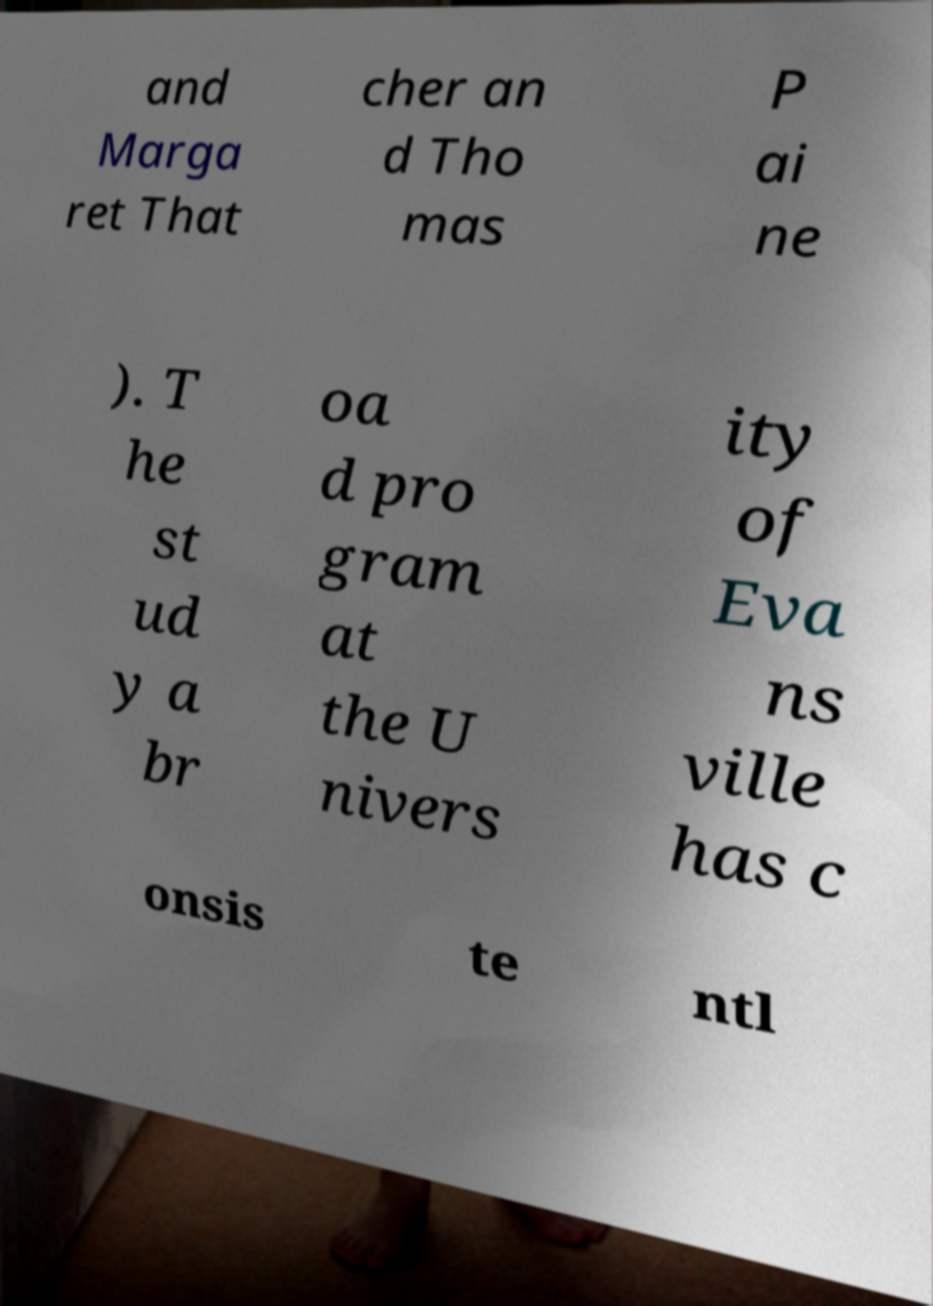I need the written content from this picture converted into text. Can you do that? and Marga ret That cher an d Tho mas P ai ne ). T he st ud y a br oa d pro gram at the U nivers ity of Eva ns ville has c onsis te ntl 